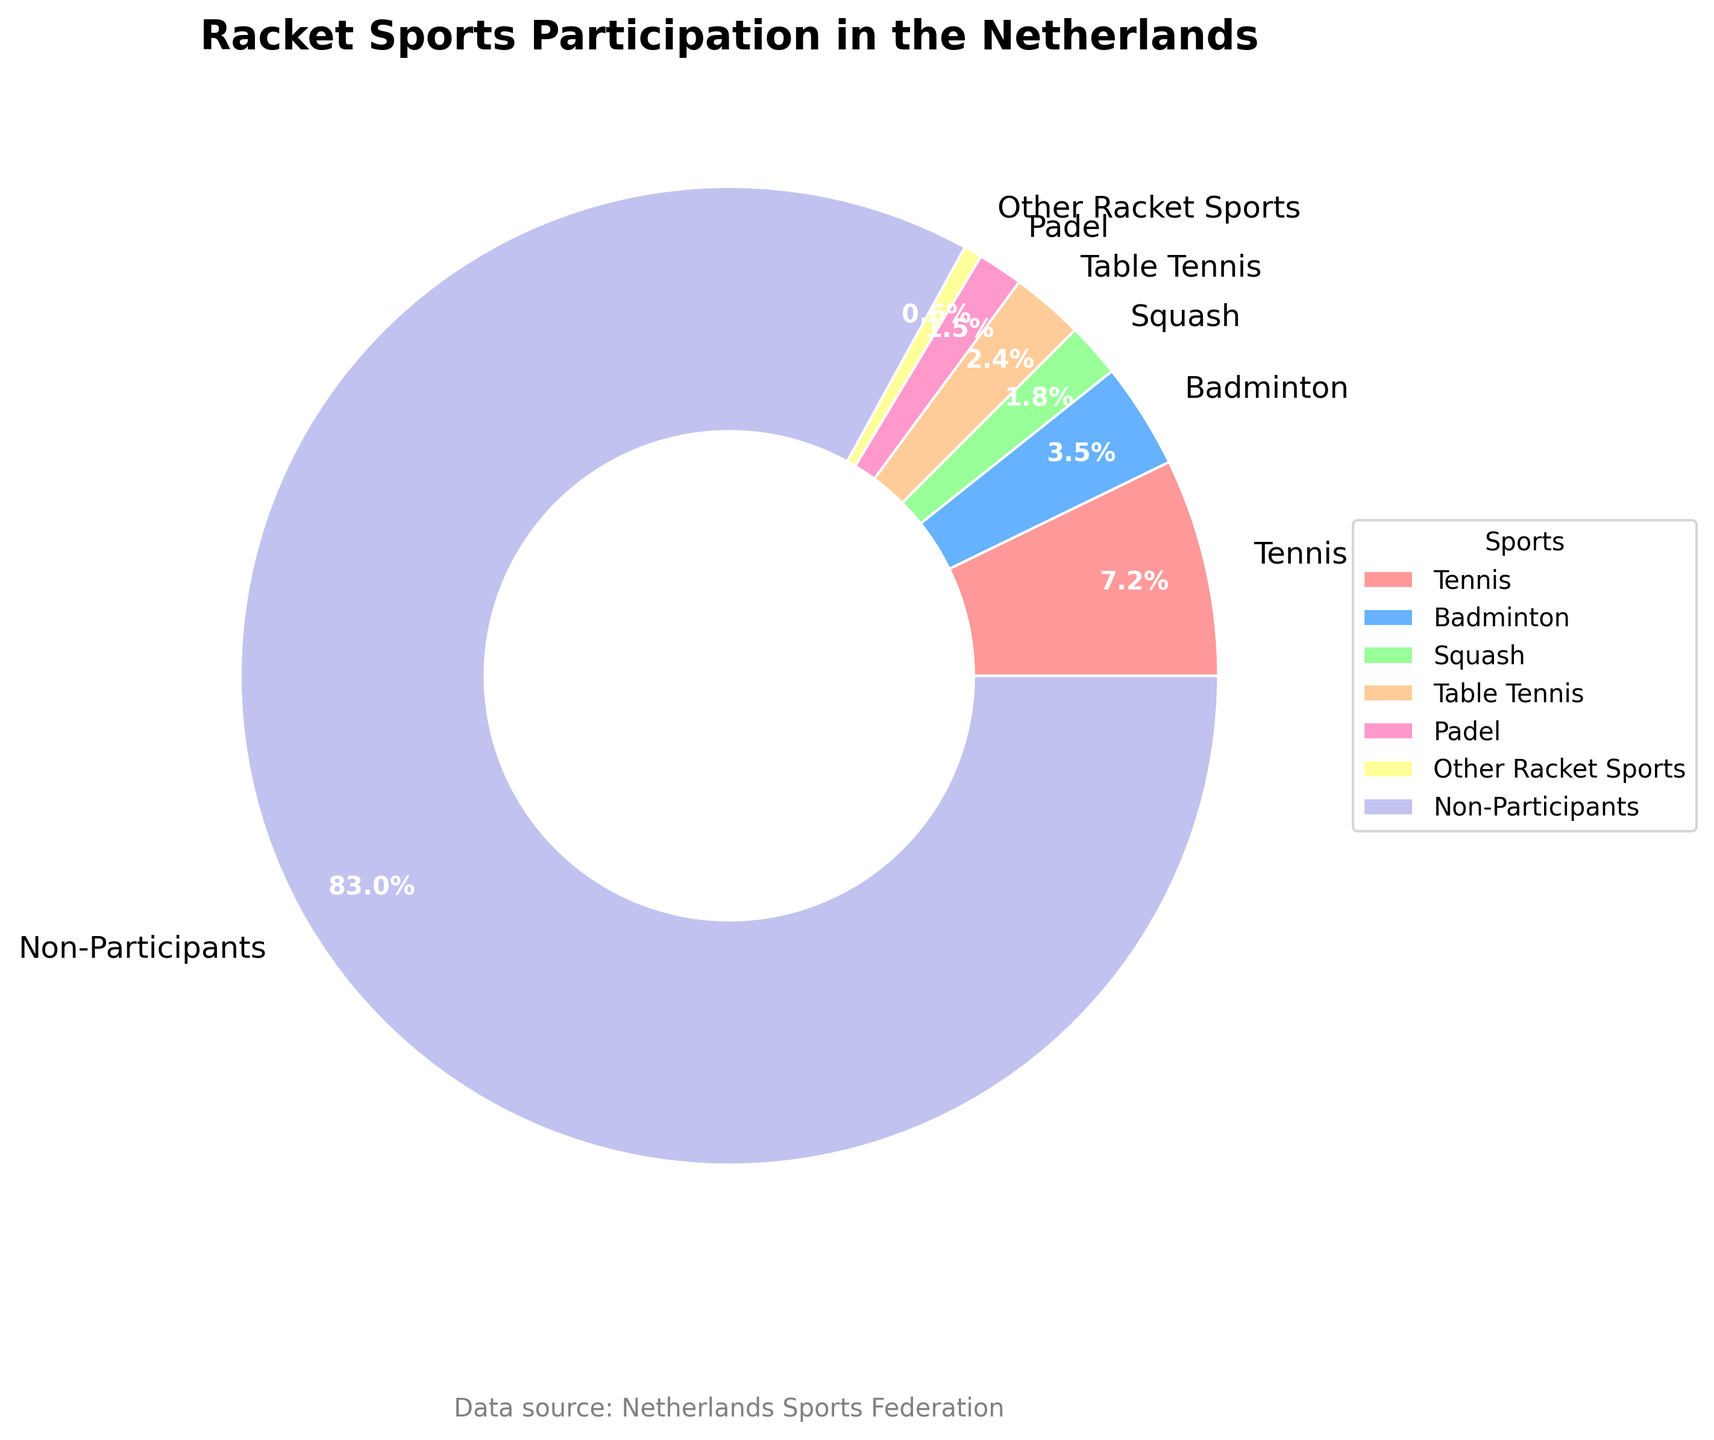What percentage of the Dutch population does not participate in racket sports? The pie chart shows a segment labeled "Non-Participants" which represents the portion of the population that does not engage in racket sports. This segment is given as 83%.
Answer: 83% Which sport has the smallest participation rate? By examining the pie chart, the smallest segment (apart from "Non-Participants") is the "Other Racket Sports" segment with a labeled percentage of 0.6%.
Answer: Other Racket Sports How many times more Dutch people participate in tennis than in padel? From the pie chart, the participation rates for tennis and padel are 7.2% and 1.5%, respectively. Dividing the percentage of tennis players by the percentage of padel players, 7.2 ÷ 1.5 ≈ 4.8, shows that roughly 4.8 times more people participate in tennis than in padel.
Answer: 4.8 times What is the combined percentage of Dutch population participating in both badminton and table tennis? The pie chart provides the percentages for badminton (3.5%) and table tennis (2.4%). Adding these values gives the combined percentage: 3.5% + 2.4% = 5.9%.
Answer: 5.9% Are there more people playing squash or badminton in the Netherlands? The pie chart shows that the percentage of people participating in squash is 1.8%, whereas that for badminton is 3.5%. Since 3.5% is greater than 1.8%, more people participate in badminton than squash.
Answer: Badminton What is the difference in the participation rates between tennis and table tennis? The pie chart indicates that tennis has a participation rate of 7.2%, and table tennis has 2.4%. The difference between these rates is 7.2% - 2.4% = 4.8%.
Answer: 4.8% Which racket sport has a similar participation rate to padel? The pie chart details the participation rates, and the rate closest to that of padel (1.5%) is squash with a rate of 1.8%.
Answer: Squash What is the average participation rate for the sports other than tennis? The pie chart provides the following percentages: badminton (3.5%), squash (1.8%), table tennis (2.4%), padel (1.5%), and other racket sports (0.6%). To find the average: (3.5 + 1.8 + 2.4 + 1.5 + 0.6) / 5 = 1.96%.
Answer: 1.96% What color is used to represent tennis on the pie chart? According to the color scheme provided in the data, the segment labeled "Tennis" is shown in a shade of red, representing its participation rate.
Answer: Red 